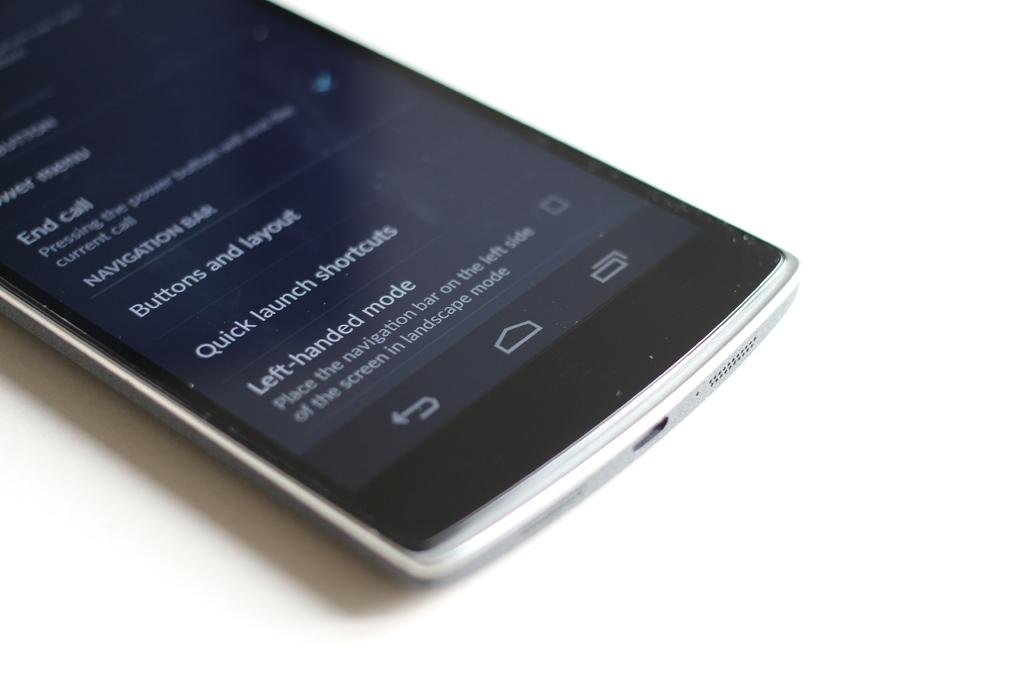<image>
Provide a brief description of the given image. Left Handed Mode options are displayed on this smart phone. 